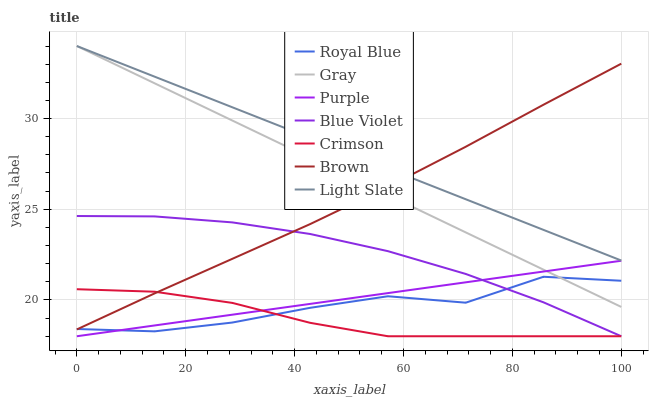Does Crimson have the minimum area under the curve?
Answer yes or no. Yes. Does Light Slate have the maximum area under the curve?
Answer yes or no. Yes. Does Gray have the minimum area under the curve?
Answer yes or no. No. Does Gray have the maximum area under the curve?
Answer yes or no. No. Is Purple the smoothest?
Answer yes or no. Yes. Is Royal Blue the roughest?
Answer yes or no. Yes. Is Gray the smoothest?
Answer yes or no. No. Is Gray the roughest?
Answer yes or no. No. Does Purple have the lowest value?
Answer yes or no. Yes. Does Gray have the lowest value?
Answer yes or no. No. Does Light Slate have the highest value?
Answer yes or no. Yes. Does Purple have the highest value?
Answer yes or no. No. Is Purple less than Light Slate?
Answer yes or no. Yes. Is Light Slate greater than Purple?
Answer yes or no. Yes. Does Gray intersect Brown?
Answer yes or no. Yes. Is Gray less than Brown?
Answer yes or no. No. Is Gray greater than Brown?
Answer yes or no. No. Does Purple intersect Light Slate?
Answer yes or no. No. 